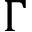Convert formula to latex. <formula><loc_0><loc_0><loc_500><loc_500>\Gamma</formula> 